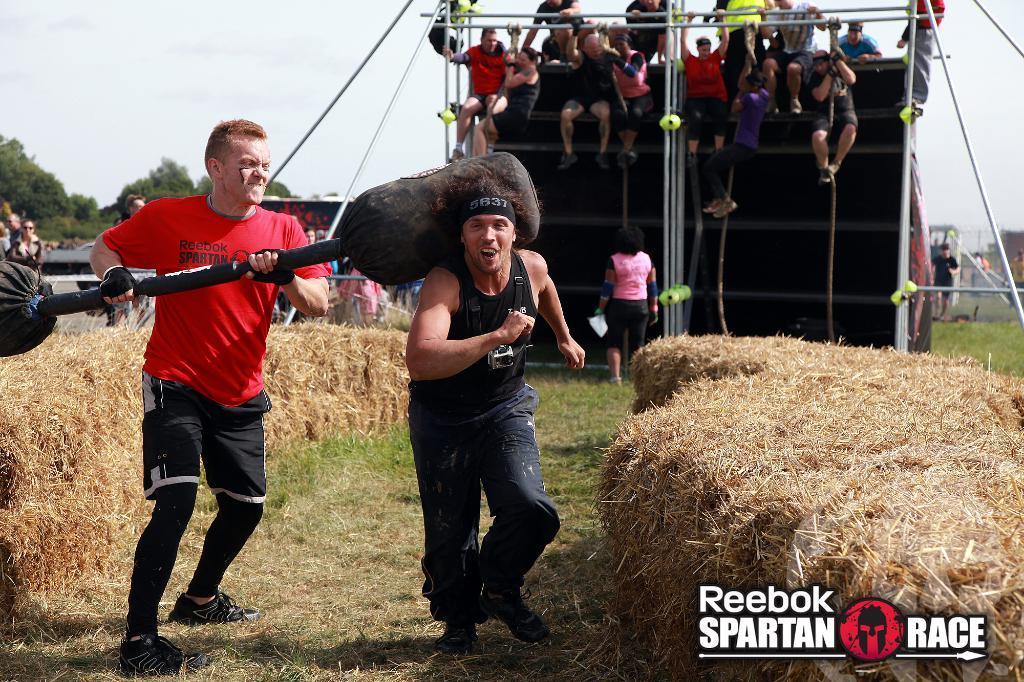Please provide a concise description of this image. In this picture the person wearing black dress is running and there is a person wearing red dress is holding an object beside him and there are few other people in the background. 